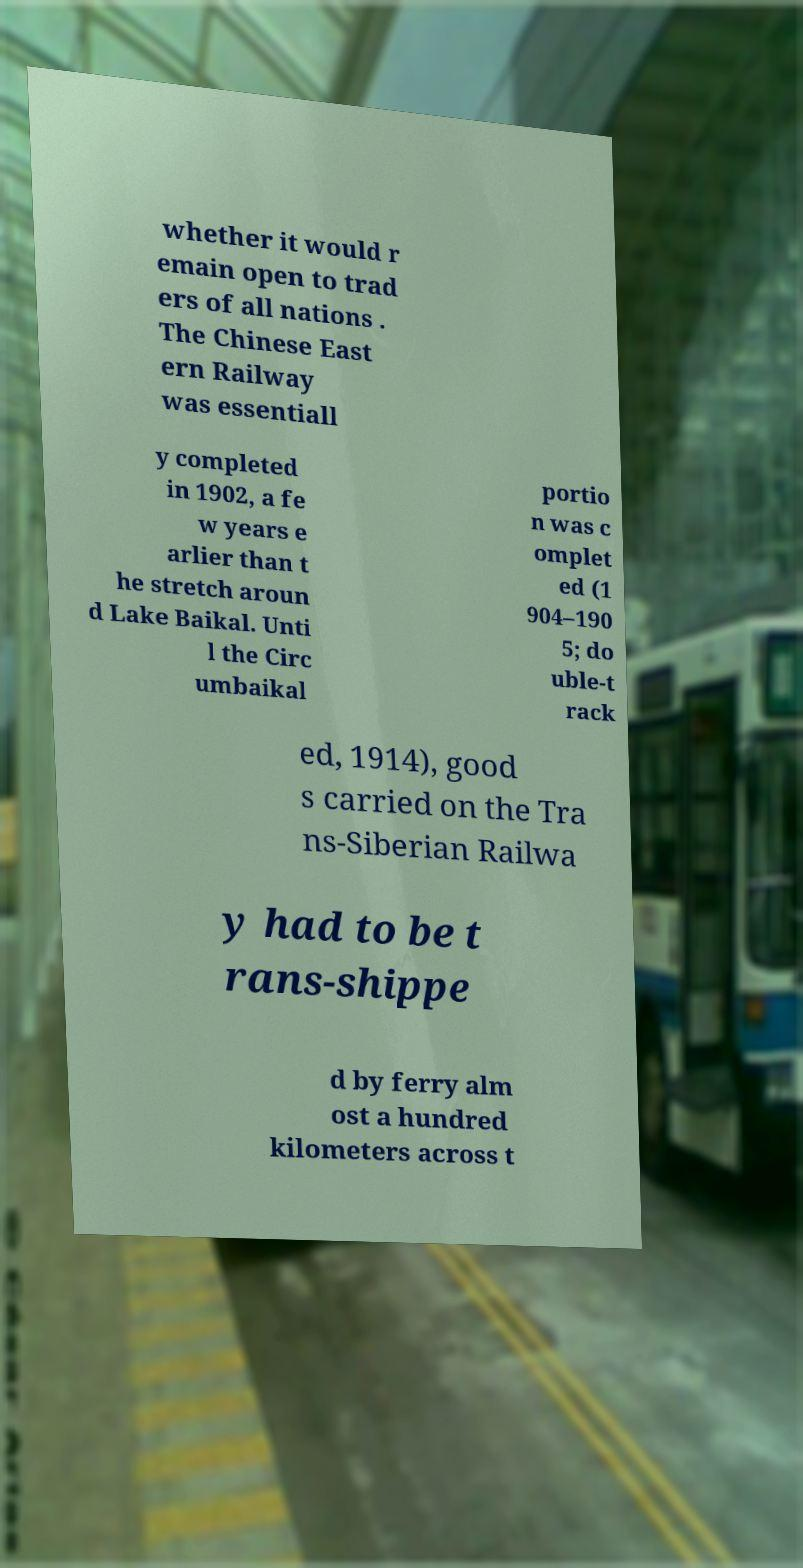I need the written content from this picture converted into text. Can you do that? whether it would r emain open to trad ers of all nations . The Chinese East ern Railway was essentiall y completed in 1902, a fe w years e arlier than t he stretch aroun d Lake Baikal. Unti l the Circ umbaikal portio n was c omplet ed (1 904–190 5; do uble-t rack ed, 1914), good s carried on the Tra ns-Siberian Railwa y had to be t rans-shippe d by ferry alm ost a hundred kilometers across t 